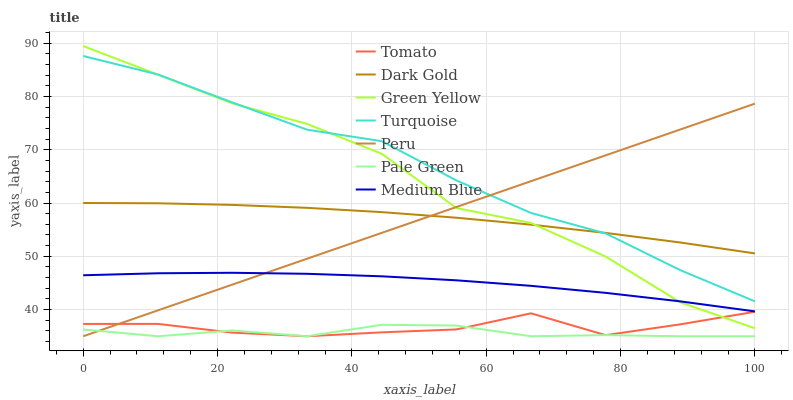Does Dark Gold have the minimum area under the curve?
Answer yes or no. No. Does Dark Gold have the maximum area under the curve?
Answer yes or no. No. Is Turquoise the smoothest?
Answer yes or no. No. Is Turquoise the roughest?
Answer yes or no. No. Does Turquoise have the lowest value?
Answer yes or no. No. Does Turquoise have the highest value?
Answer yes or no. No. Is Pale Green less than Dark Gold?
Answer yes or no. Yes. Is Dark Gold greater than Tomato?
Answer yes or no. Yes. Does Pale Green intersect Dark Gold?
Answer yes or no. No. 